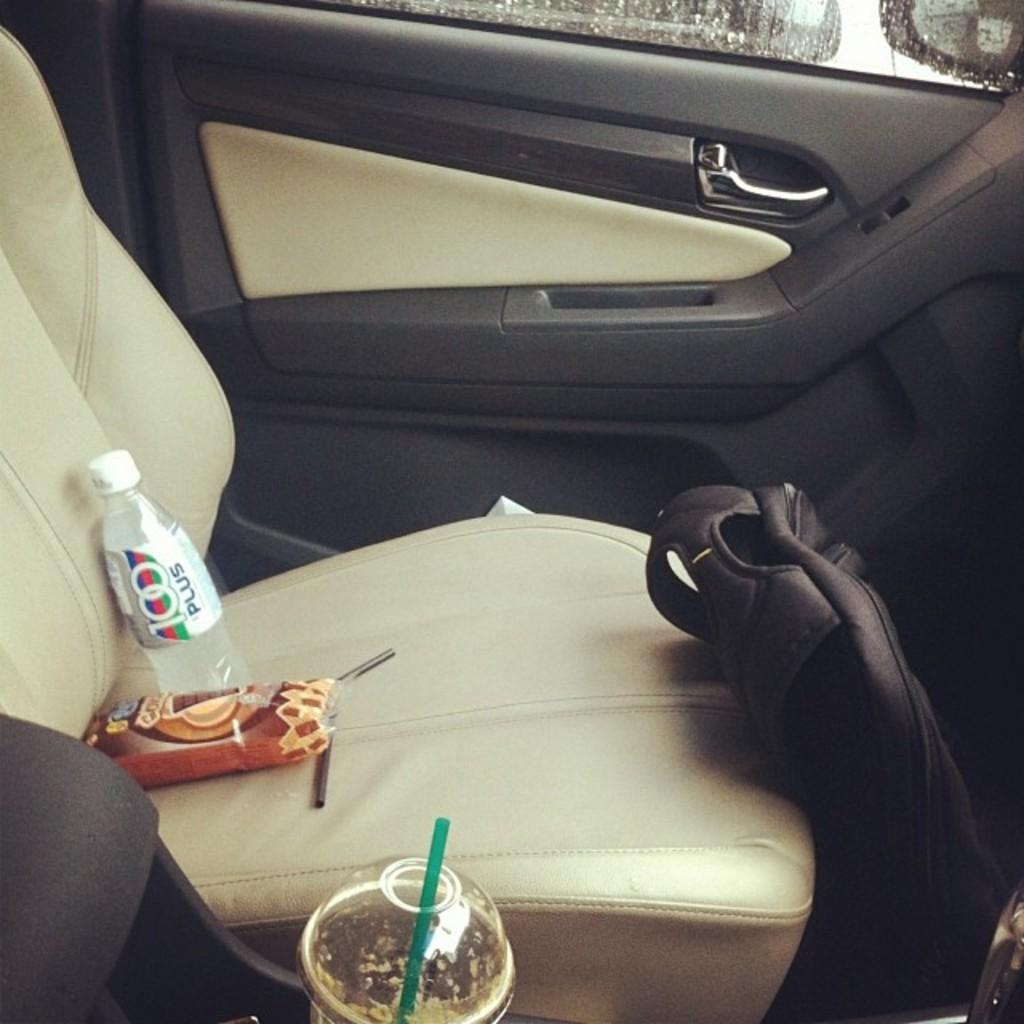Where was the image taken? The image is taken inside a car. What can be seen in the car in the image? There is a car seat and a bag in front of the car seat in the image. What is on the car seat? There are food items on the car seat in the image. What type of advice can be seen written on the car seat in the image? There is no advice written on the car seat in the image; it is a car seat with food items on it. 